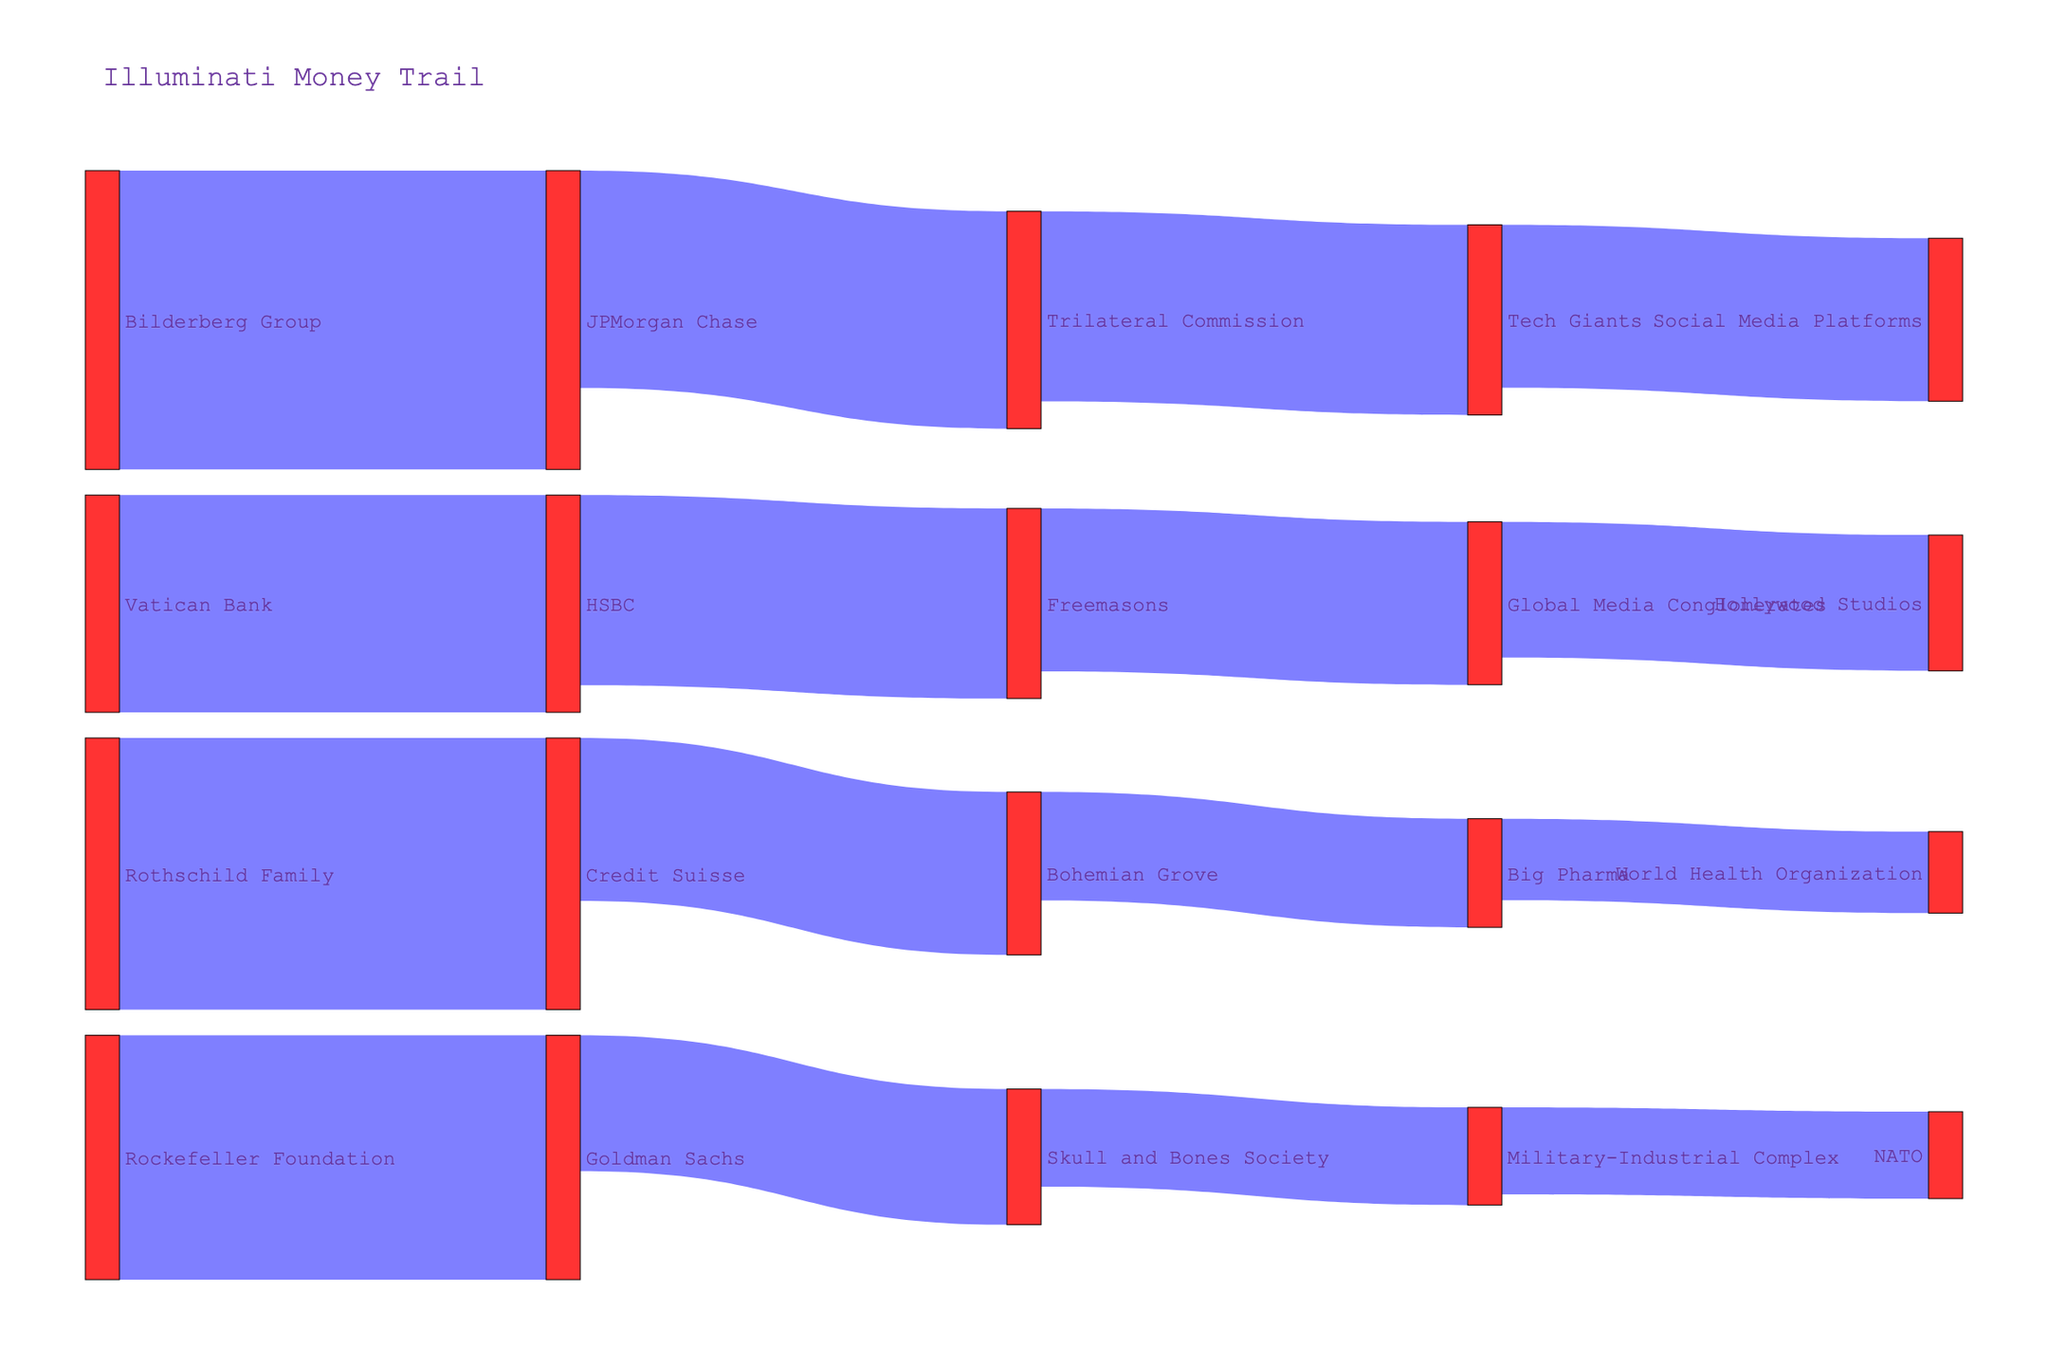who funds HSBC? To find out who funds HSBC, trace the arrows leading into the HSBC node. According to the diagram, the Vatican Bank funds HSBC with a value of 400.
Answer: Vatican Bank Where does the money from the Rockefeller Foundation go? To understand where the money from the Rockefeller Foundation goes, follow the arrow leading out from Rockefeller Foundation. It points to Goldman Sachs with a value of 450.
Answer: Goldman Sachs How much money is transferred from Bohemian Grove to Big Pharma? Locate the arrow connecting Bohemian Grove to Big Pharma. The value labeled on this arrow is 200.
Answer: 200 Which entity receives the highest amount of funding? Compare the values of all outgoing arrows from each source entity. Bilderberg Group to JPMorgan Chase has the maximum value of 550.
Answer: JPMorgan Chase Add the total funding amounts going to Trilateral Commission and Skull and Bones Society. First, identify the values of arrows leading to Trilateral Commission and Skull and Bones Society. They receive 400 and 250 respectively. Then, add these amounts together: 400 + 250 = 650.
Answer: 650 What are the groups receiving funds from the Freemasons? Follow the arrows originating from the Freemasons node. They lead to Global Media Conglomerates with a value of 300.
Answer: Global Media Conglomerates Is the value of funds transferred from Global Media Conglomerates to Hollywood Studios greater than the funds transferred from Military-Industrial Complex to NATO? Compare the values of the arrows: Global Media Conglomerates to Hollywood Studios is 250, and Military-Industrial Complex to NATO is 160. 250 is greater than 160.
Answer: Yes List the three entities that get funded by financial institutions. Identify the arrows leading out from entities labeled as banks (Credit Suisse, Goldman Sachs, HSBC, JPMorgan Chase). Their target nodes are Bohemian Grove, Skull and Bones Society, Freemasons, Trilateral Commission. Three entities are Skull and Bones Society, Freemasons, Trilateral Commission.
Answer: Skull and Bones Society, Freemasons, Trilateral Commission Who provides funds to Big Pharma and Social Media Platforms? Follow the arrows leading into Big Pharma and Social Media Platforms. Big Pharma is funded by Bohemian Grove with 200, and Social Media Platforms are funded by Tech Giants with 300.
Answer: Bohemian Grove and Tech Giants 